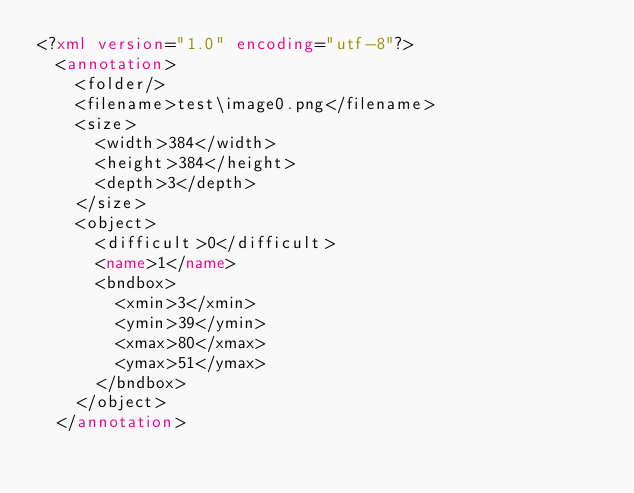<code> <loc_0><loc_0><loc_500><loc_500><_XML_><?xml version="1.0" encoding="utf-8"?>
	<annotation>
		<folder/>
		<filename>test\image0.png</filename>
		<size>
			<width>384</width>
			<height>384</height>
			<depth>3</depth>
		</size>
		<object>
			<difficult>0</difficult>
			<name>1</name>
			<bndbox>
				<xmin>3</xmin>
				<ymin>39</ymin>
				<xmax>80</xmax>
				<ymax>51</ymax>
			</bndbox>
		</object>
	</annotation>
</code> 